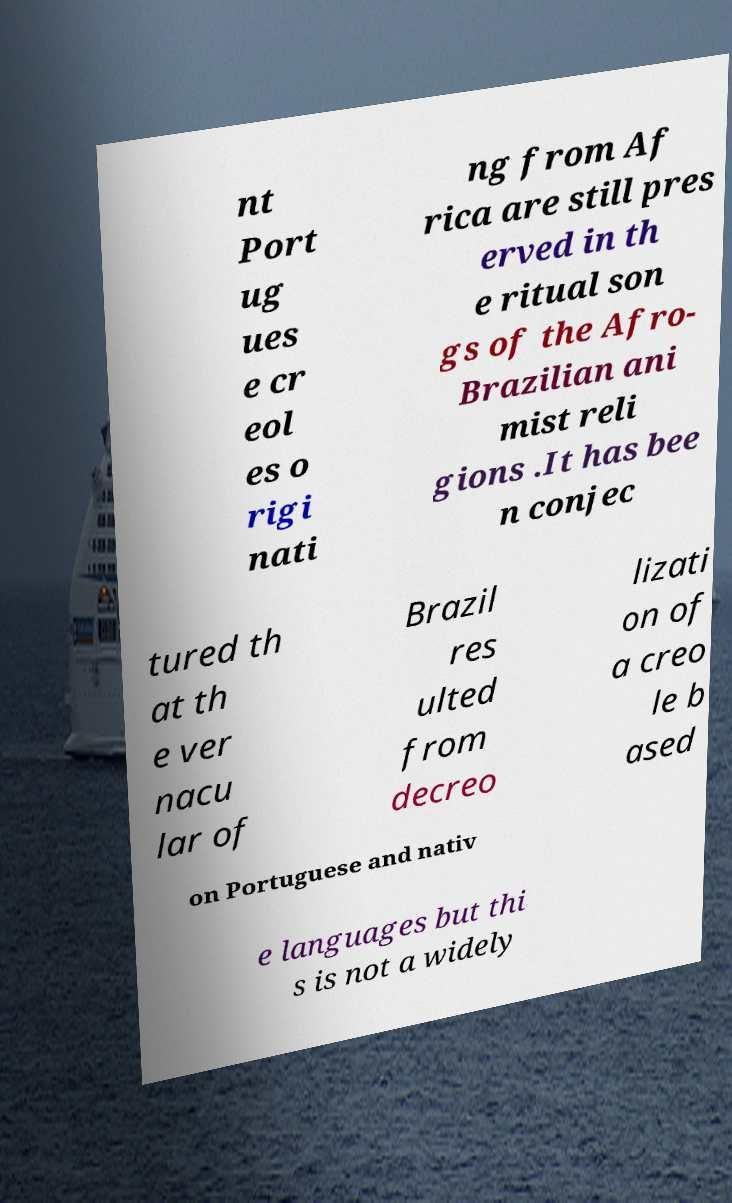Please identify and transcribe the text found in this image. nt Port ug ues e cr eol es o rigi nati ng from Af rica are still pres erved in th e ritual son gs of the Afro- Brazilian ani mist reli gions .It has bee n conjec tured th at th e ver nacu lar of Brazil res ulted from decreo lizati on of a creo le b ased on Portuguese and nativ e languages but thi s is not a widely 